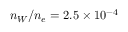Convert formula to latex. <formula><loc_0><loc_0><loc_500><loc_500>n _ { W } / n _ { e } = 2 . 5 \times 1 0 ^ { - 4 }</formula> 